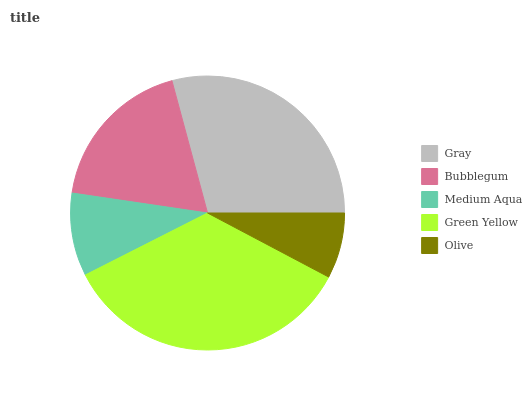Is Olive the minimum?
Answer yes or no. Yes. Is Green Yellow the maximum?
Answer yes or no. Yes. Is Bubblegum the minimum?
Answer yes or no. No. Is Bubblegum the maximum?
Answer yes or no. No. Is Gray greater than Bubblegum?
Answer yes or no. Yes. Is Bubblegum less than Gray?
Answer yes or no. Yes. Is Bubblegum greater than Gray?
Answer yes or no. No. Is Gray less than Bubblegum?
Answer yes or no. No. Is Bubblegum the high median?
Answer yes or no. Yes. Is Bubblegum the low median?
Answer yes or no. Yes. Is Gray the high median?
Answer yes or no. No. Is Green Yellow the low median?
Answer yes or no. No. 